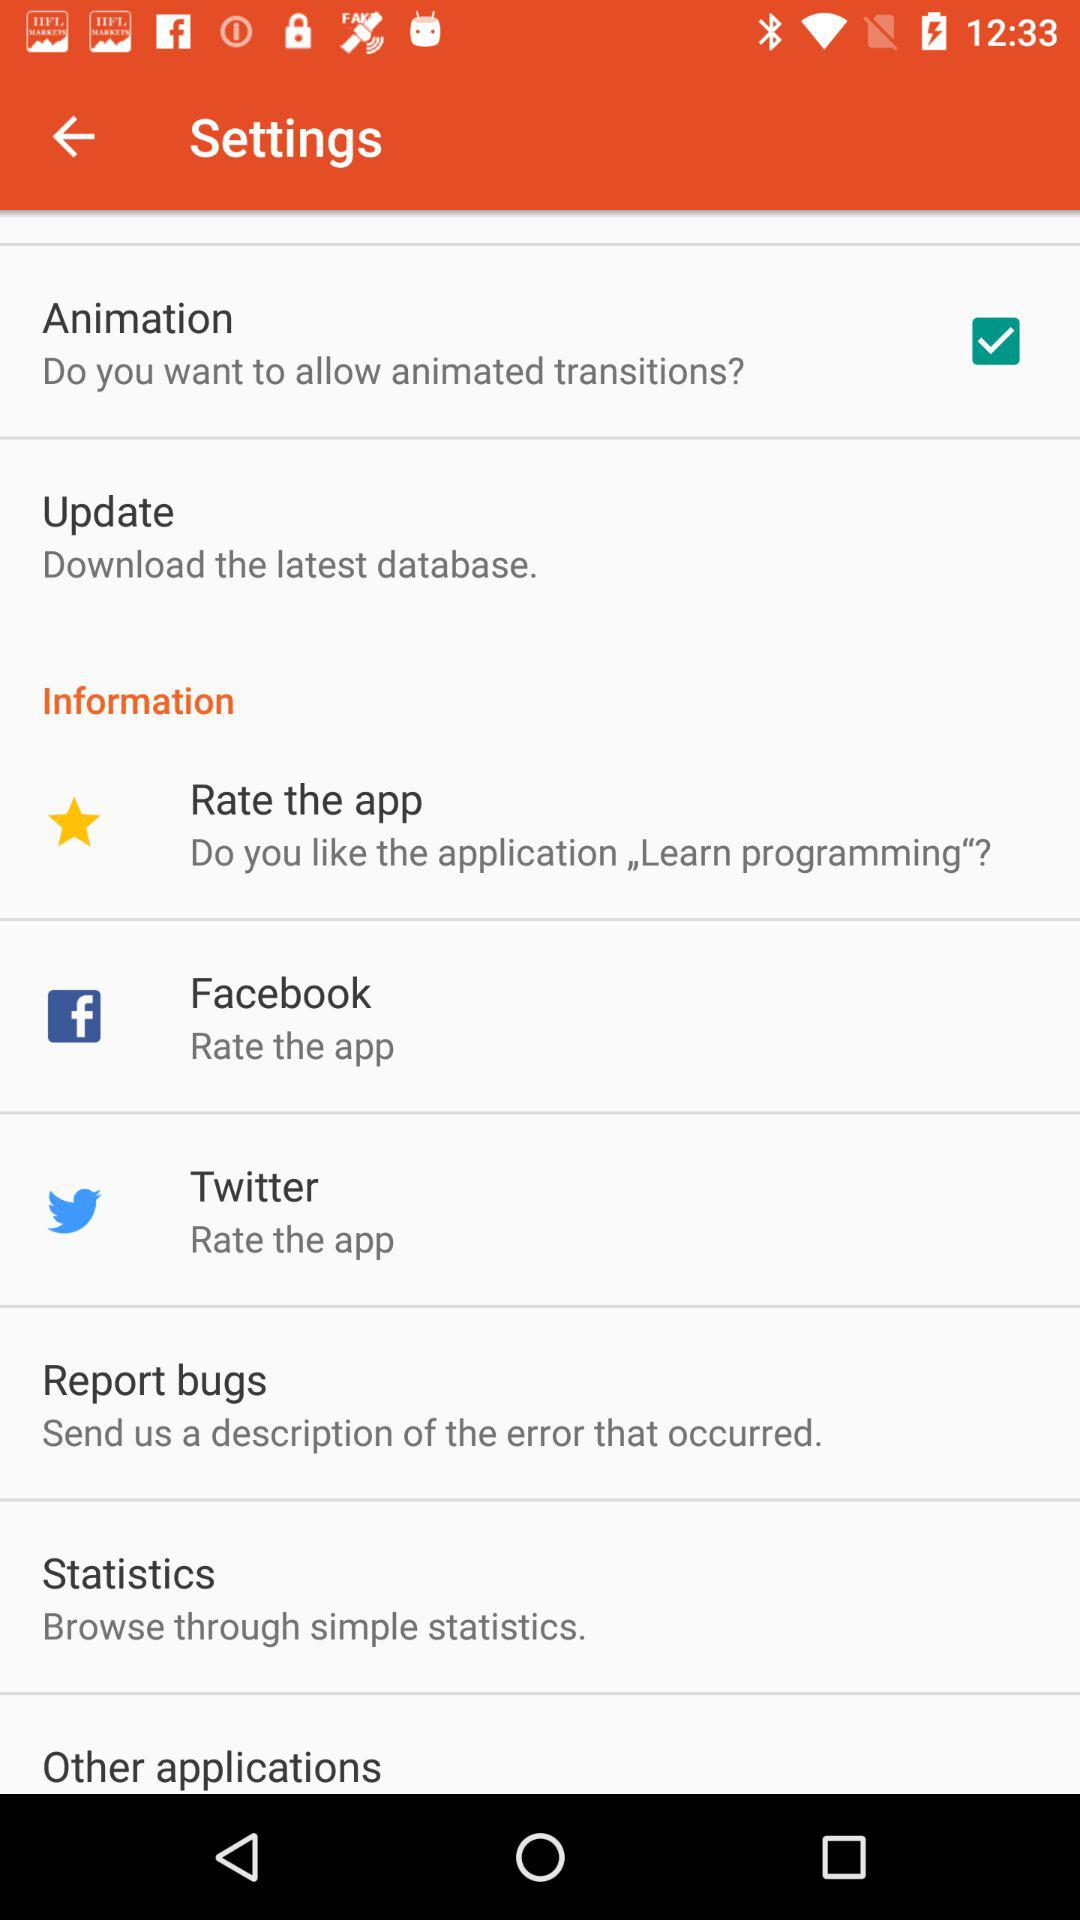What is the status of "Animation"? The status of "Animation" is "on". 